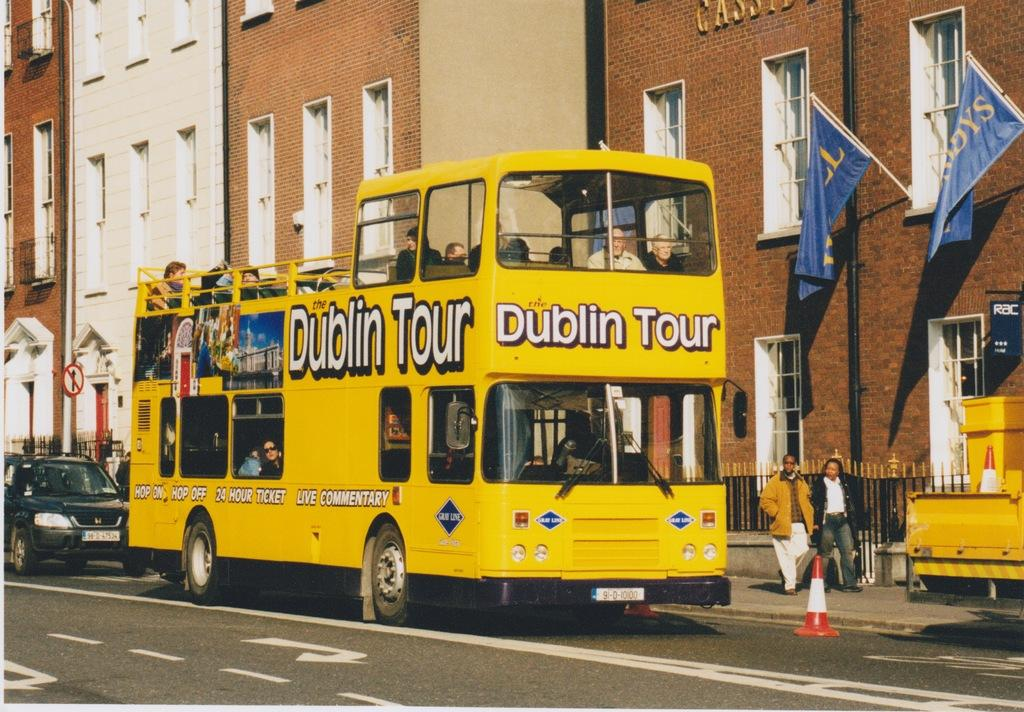<image>
Summarize the visual content of the image. A yellow Dublin Tour double decker bus on a street 